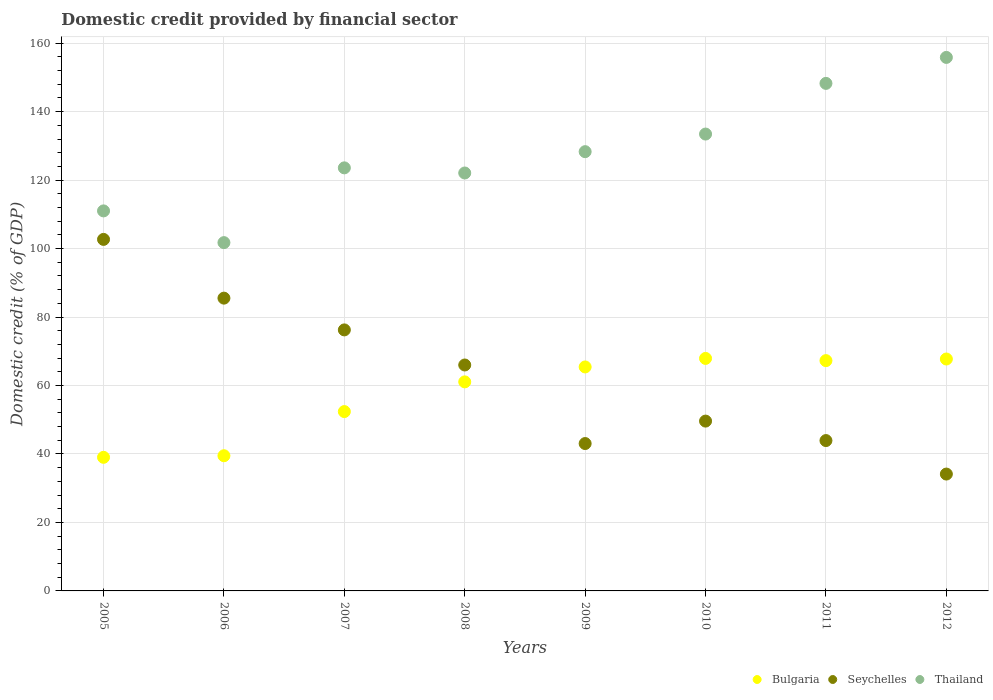How many different coloured dotlines are there?
Your answer should be compact. 3. Is the number of dotlines equal to the number of legend labels?
Offer a very short reply. Yes. What is the domestic credit in Bulgaria in 2010?
Ensure brevity in your answer.  67.92. Across all years, what is the maximum domestic credit in Bulgaria?
Give a very brief answer. 67.92. Across all years, what is the minimum domestic credit in Bulgaria?
Offer a terse response. 39.03. In which year was the domestic credit in Seychelles maximum?
Ensure brevity in your answer.  2005. What is the total domestic credit in Seychelles in the graph?
Ensure brevity in your answer.  501.2. What is the difference between the domestic credit in Bulgaria in 2007 and that in 2009?
Give a very brief answer. -13.04. What is the difference between the domestic credit in Thailand in 2006 and the domestic credit in Bulgaria in 2008?
Offer a terse response. 40.68. What is the average domestic credit in Seychelles per year?
Your answer should be very brief. 62.65. In the year 2006, what is the difference between the domestic credit in Bulgaria and domestic credit in Seychelles?
Ensure brevity in your answer.  -46.04. In how many years, is the domestic credit in Thailand greater than 36 %?
Offer a very short reply. 8. What is the ratio of the domestic credit in Thailand in 2008 to that in 2010?
Offer a very short reply. 0.91. Is the difference between the domestic credit in Bulgaria in 2010 and 2012 greater than the difference between the domestic credit in Seychelles in 2010 and 2012?
Give a very brief answer. No. What is the difference between the highest and the second highest domestic credit in Thailand?
Your response must be concise. 7.59. What is the difference between the highest and the lowest domestic credit in Seychelles?
Your answer should be very brief. 68.55. Is the sum of the domestic credit in Seychelles in 2007 and 2010 greater than the maximum domestic credit in Bulgaria across all years?
Keep it short and to the point. Yes. Is it the case that in every year, the sum of the domestic credit in Seychelles and domestic credit in Bulgaria  is greater than the domestic credit in Thailand?
Provide a short and direct response. No. Is the domestic credit in Seychelles strictly less than the domestic credit in Thailand over the years?
Offer a terse response. Yes. Where does the legend appear in the graph?
Give a very brief answer. Bottom right. What is the title of the graph?
Offer a very short reply. Domestic credit provided by financial sector. What is the label or title of the X-axis?
Offer a terse response. Years. What is the label or title of the Y-axis?
Provide a succinct answer. Domestic credit (% of GDP). What is the Domestic credit (% of GDP) of Bulgaria in 2005?
Your answer should be compact. 39.03. What is the Domestic credit (% of GDP) of Seychelles in 2005?
Provide a short and direct response. 102.69. What is the Domestic credit (% of GDP) of Thailand in 2005?
Give a very brief answer. 111.02. What is the Domestic credit (% of GDP) of Bulgaria in 2006?
Your answer should be compact. 39.49. What is the Domestic credit (% of GDP) of Seychelles in 2006?
Your answer should be compact. 85.53. What is the Domestic credit (% of GDP) in Thailand in 2006?
Your answer should be very brief. 101.75. What is the Domestic credit (% of GDP) of Bulgaria in 2007?
Ensure brevity in your answer.  52.39. What is the Domestic credit (% of GDP) of Seychelles in 2007?
Ensure brevity in your answer.  76.25. What is the Domestic credit (% of GDP) in Thailand in 2007?
Offer a terse response. 123.59. What is the Domestic credit (% of GDP) in Bulgaria in 2008?
Your answer should be compact. 61.07. What is the Domestic credit (% of GDP) of Seychelles in 2008?
Your response must be concise. 66. What is the Domestic credit (% of GDP) of Thailand in 2008?
Your answer should be compact. 122.09. What is the Domestic credit (% of GDP) of Bulgaria in 2009?
Offer a terse response. 65.43. What is the Domestic credit (% of GDP) of Seychelles in 2009?
Provide a succinct answer. 43.05. What is the Domestic credit (% of GDP) in Thailand in 2009?
Your answer should be very brief. 128.32. What is the Domestic credit (% of GDP) of Bulgaria in 2010?
Your response must be concise. 67.92. What is the Domestic credit (% of GDP) in Seychelles in 2010?
Keep it short and to the point. 49.61. What is the Domestic credit (% of GDP) in Thailand in 2010?
Provide a succinct answer. 133.46. What is the Domestic credit (% of GDP) of Bulgaria in 2011?
Give a very brief answer. 67.28. What is the Domestic credit (% of GDP) of Seychelles in 2011?
Make the answer very short. 43.92. What is the Domestic credit (% of GDP) in Thailand in 2011?
Keep it short and to the point. 148.27. What is the Domestic credit (% of GDP) in Bulgaria in 2012?
Provide a short and direct response. 67.75. What is the Domestic credit (% of GDP) of Seychelles in 2012?
Ensure brevity in your answer.  34.14. What is the Domestic credit (% of GDP) of Thailand in 2012?
Offer a very short reply. 155.86. Across all years, what is the maximum Domestic credit (% of GDP) in Bulgaria?
Your response must be concise. 67.92. Across all years, what is the maximum Domestic credit (% of GDP) of Seychelles?
Your answer should be compact. 102.69. Across all years, what is the maximum Domestic credit (% of GDP) of Thailand?
Provide a succinct answer. 155.86. Across all years, what is the minimum Domestic credit (% of GDP) in Bulgaria?
Provide a succinct answer. 39.03. Across all years, what is the minimum Domestic credit (% of GDP) of Seychelles?
Offer a terse response. 34.14. Across all years, what is the minimum Domestic credit (% of GDP) of Thailand?
Your answer should be compact. 101.75. What is the total Domestic credit (% of GDP) in Bulgaria in the graph?
Offer a very short reply. 460.37. What is the total Domestic credit (% of GDP) of Seychelles in the graph?
Offer a terse response. 501.2. What is the total Domestic credit (% of GDP) in Thailand in the graph?
Provide a short and direct response. 1024.36. What is the difference between the Domestic credit (% of GDP) of Bulgaria in 2005 and that in 2006?
Give a very brief answer. -0.47. What is the difference between the Domestic credit (% of GDP) in Seychelles in 2005 and that in 2006?
Your answer should be compact. 17.16. What is the difference between the Domestic credit (% of GDP) of Thailand in 2005 and that in 2006?
Make the answer very short. 9.27. What is the difference between the Domestic credit (% of GDP) of Bulgaria in 2005 and that in 2007?
Provide a succinct answer. -13.36. What is the difference between the Domestic credit (% of GDP) of Seychelles in 2005 and that in 2007?
Ensure brevity in your answer.  26.44. What is the difference between the Domestic credit (% of GDP) in Thailand in 2005 and that in 2007?
Offer a terse response. -12.57. What is the difference between the Domestic credit (% of GDP) in Bulgaria in 2005 and that in 2008?
Ensure brevity in your answer.  -22.04. What is the difference between the Domestic credit (% of GDP) of Seychelles in 2005 and that in 2008?
Keep it short and to the point. 36.69. What is the difference between the Domestic credit (% of GDP) of Thailand in 2005 and that in 2008?
Provide a short and direct response. -11.07. What is the difference between the Domestic credit (% of GDP) of Bulgaria in 2005 and that in 2009?
Your response must be concise. -26.4. What is the difference between the Domestic credit (% of GDP) in Seychelles in 2005 and that in 2009?
Provide a short and direct response. 59.64. What is the difference between the Domestic credit (% of GDP) in Thailand in 2005 and that in 2009?
Provide a succinct answer. -17.3. What is the difference between the Domestic credit (% of GDP) of Bulgaria in 2005 and that in 2010?
Keep it short and to the point. -28.89. What is the difference between the Domestic credit (% of GDP) in Seychelles in 2005 and that in 2010?
Keep it short and to the point. 53.08. What is the difference between the Domestic credit (% of GDP) in Thailand in 2005 and that in 2010?
Make the answer very short. -22.45. What is the difference between the Domestic credit (% of GDP) in Bulgaria in 2005 and that in 2011?
Offer a very short reply. -28.25. What is the difference between the Domestic credit (% of GDP) of Seychelles in 2005 and that in 2011?
Offer a terse response. 58.77. What is the difference between the Domestic credit (% of GDP) in Thailand in 2005 and that in 2011?
Your answer should be very brief. -37.25. What is the difference between the Domestic credit (% of GDP) in Bulgaria in 2005 and that in 2012?
Provide a succinct answer. -28.72. What is the difference between the Domestic credit (% of GDP) of Seychelles in 2005 and that in 2012?
Provide a short and direct response. 68.55. What is the difference between the Domestic credit (% of GDP) in Thailand in 2005 and that in 2012?
Your answer should be compact. -44.84. What is the difference between the Domestic credit (% of GDP) in Bulgaria in 2006 and that in 2007?
Offer a very short reply. -12.9. What is the difference between the Domestic credit (% of GDP) in Seychelles in 2006 and that in 2007?
Give a very brief answer. 9.28. What is the difference between the Domestic credit (% of GDP) in Thailand in 2006 and that in 2007?
Give a very brief answer. -21.84. What is the difference between the Domestic credit (% of GDP) in Bulgaria in 2006 and that in 2008?
Your answer should be compact. -21.58. What is the difference between the Domestic credit (% of GDP) of Seychelles in 2006 and that in 2008?
Your response must be concise. 19.53. What is the difference between the Domestic credit (% of GDP) in Thailand in 2006 and that in 2008?
Make the answer very short. -20.34. What is the difference between the Domestic credit (% of GDP) in Bulgaria in 2006 and that in 2009?
Give a very brief answer. -25.94. What is the difference between the Domestic credit (% of GDP) of Seychelles in 2006 and that in 2009?
Ensure brevity in your answer.  42.48. What is the difference between the Domestic credit (% of GDP) of Thailand in 2006 and that in 2009?
Your answer should be compact. -26.57. What is the difference between the Domestic credit (% of GDP) in Bulgaria in 2006 and that in 2010?
Your response must be concise. -28.43. What is the difference between the Domestic credit (% of GDP) in Seychelles in 2006 and that in 2010?
Provide a succinct answer. 35.92. What is the difference between the Domestic credit (% of GDP) in Thailand in 2006 and that in 2010?
Your answer should be compact. -31.71. What is the difference between the Domestic credit (% of GDP) of Bulgaria in 2006 and that in 2011?
Your answer should be compact. -27.78. What is the difference between the Domestic credit (% of GDP) of Seychelles in 2006 and that in 2011?
Provide a succinct answer. 41.61. What is the difference between the Domestic credit (% of GDP) in Thailand in 2006 and that in 2011?
Provide a short and direct response. -46.52. What is the difference between the Domestic credit (% of GDP) of Bulgaria in 2006 and that in 2012?
Your answer should be compact. -28.26. What is the difference between the Domestic credit (% of GDP) in Seychelles in 2006 and that in 2012?
Make the answer very short. 51.39. What is the difference between the Domestic credit (% of GDP) of Thailand in 2006 and that in 2012?
Your answer should be compact. -54.11. What is the difference between the Domestic credit (% of GDP) in Bulgaria in 2007 and that in 2008?
Your answer should be very brief. -8.68. What is the difference between the Domestic credit (% of GDP) in Seychelles in 2007 and that in 2008?
Make the answer very short. 10.25. What is the difference between the Domestic credit (% of GDP) of Thailand in 2007 and that in 2008?
Give a very brief answer. 1.5. What is the difference between the Domestic credit (% of GDP) of Bulgaria in 2007 and that in 2009?
Your response must be concise. -13.04. What is the difference between the Domestic credit (% of GDP) of Seychelles in 2007 and that in 2009?
Your response must be concise. 33.2. What is the difference between the Domestic credit (% of GDP) of Thailand in 2007 and that in 2009?
Ensure brevity in your answer.  -4.73. What is the difference between the Domestic credit (% of GDP) in Bulgaria in 2007 and that in 2010?
Provide a succinct answer. -15.53. What is the difference between the Domestic credit (% of GDP) of Seychelles in 2007 and that in 2010?
Provide a short and direct response. 26.64. What is the difference between the Domestic credit (% of GDP) of Thailand in 2007 and that in 2010?
Provide a succinct answer. -9.87. What is the difference between the Domestic credit (% of GDP) of Bulgaria in 2007 and that in 2011?
Give a very brief answer. -14.88. What is the difference between the Domestic credit (% of GDP) in Seychelles in 2007 and that in 2011?
Your answer should be compact. 32.33. What is the difference between the Domestic credit (% of GDP) in Thailand in 2007 and that in 2011?
Provide a succinct answer. -24.68. What is the difference between the Domestic credit (% of GDP) of Bulgaria in 2007 and that in 2012?
Your answer should be very brief. -15.36. What is the difference between the Domestic credit (% of GDP) in Seychelles in 2007 and that in 2012?
Provide a succinct answer. 42.11. What is the difference between the Domestic credit (% of GDP) in Thailand in 2007 and that in 2012?
Give a very brief answer. -32.27. What is the difference between the Domestic credit (% of GDP) in Bulgaria in 2008 and that in 2009?
Your response must be concise. -4.36. What is the difference between the Domestic credit (% of GDP) in Seychelles in 2008 and that in 2009?
Offer a terse response. 22.95. What is the difference between the Domestic credit (% of GDP) in Thailand in 2008 and that in 2009?
Offer a terse response. -6.23. What is the difference between the Domestic credit (% of GDP) of Bulgaria in 2008 and that in 2010?
Provide a succinct answer. -6.85. What is the difference between the Domestic credit (% of GDP) in Seychelles in 2008 and that in 2010?
Provide a short and direct response. 16.39. What is the difference between the Domestic credit (% of GDP) of Thailand in 2008 and that in 2010?
Provide a succinct answer. -11.37. What is the difference between the Domestic credit (% of GDP) in Bulgaria in 2008 and that in 2011?
Your answer should be very brief. -6.2. What is the difference between the Domestic credit (% of GDP) of Seychelles in 2008 and that in 2011?
Provide a succinct answer. 22.08. What is the difference between the Domestic credit (% of GDP) in Thailand in 2008 and that in 2011?
Provide a succinct answer. -26.18. What is the difference between the Domestic credit (% of GDP) of Bulgaria in 2008 and that in 2012?
Offer a very short reply. -6.68. What is the difference between the Domestic credit (% of GDP) of Seychelles in 2008 and that in 2012?
Your answer should be very brief. 31.86. What is the difference between the Domestic credit (% of GDP) in Thailand in 2008 and that in 2012?
Provide a short and direct response. -33.77. What is the difference between the Domestic credit (% of GDP) in Bulgaria in 2009 and that in 2010?
Your response must be concise. -2.49. What is the difference between the Domestic credit (% of GDP) in Seychelles in 2009 and that in 2010?
Your answer should be very brief. -6.56. What is the difference between the Domestic credit (% of GDP) in Thailand in 2009 and that in 2010?
Provide a short and direct response. -5.14. What is the difference between the Domestic credit (% of GDP) in Bulgaria in 2009 and that in 2011?
Give a very brief answer. -1.84. What is the difference between the Domestic credit (% of GDP) of Seychelles in 2009 and that in 2011?
Offer a terse response. -0.87. What is the difference between the Domestic credit (% of GDP) in Thailand in 2009 and that in 2011?
Your answer should be very brief. -19.95. What is the difference between the Domestic credit (% of GDP) of Bulgaria in 2009 and that in 2012?
Make the answer very short. -2.32. What is the difference between the Domestic credit (% of GDP) of Seychelles in 2009 and that in 2012?
Give a very brief answer. 8.92. What is the difference between the Domestic credit (% of GDP) of Thailand in 2009 and that in 2012?
Give a very brief answer. -27.54. What is the difference between the Domestic credit (% of GDP) of Bulgaria in 2010 and that in 2011?
Your answer should be very brief. 0.65. What is the difference between the Domestic credit (% of GDP) of Seychelles in 2010 and that in 2011?
Your answer should be compact. 5.69. What is the difference between the Domestic credit (% of GDP) of Thailand in 2010 and that in 2011?
Your response must be concise. -14.8. What is the difference between the Domestic credit (% of GDP) of Bulgaria in 2010 and that in 2012?
Ensure brevity in your answer.  0.17. What is the difference between the Domestic credit (% of GDP) in Seychelles in 2010 and that in 2012?
Make the answer very short. 15.47. What is the difference between the Domestic credit (% of GDP) in Thailand in 2010 and that in 2012?
Give a very brief answer. -22.39. What is the difference between the Domestic credit (% of GDP) in Bulgaria in 2011 and that in 2012?
Provide a succinct answer. -0.47. What is the difference between the Domestic credit (% of GDP) of Seychelles in 2011 and that in 2012?
Your response must be concise. 9.78. What is the difference between the Domestic credit (% of GDP) in Thailand in 2011 and that in 2012?
Offer a terse response. -7.59. What is the difference between the Domestic credit (% of GDP) in Bulgaria in 2005 and the Domestic credit (% of GDP) in Seychelles in 2006?
Offer a very short reply. -46.5. What is the difference between the Domestic credit (% of GDP) in Bulgaria in 2005 and the Domestic credit (% of GDP) in Thailand in 2006?
Offer a terse response. -62.72. What is the difference between the Domestic credit (% of GDP) in Seychelles in 2005 and the Domestic credit (% of GDP) in Thailand in 2006?
Make the answer very short. 0.94. What is the difference between the Domestic credit (% of GDP) of Bulgaria in 2005 and the Domestic credit (% of GDP) of Seychelles in 2007?
Your answer should be very brief. -37.22. What is the difference between the Domestic credit (% of GDP) of Bulgaria in 2005 and the Domestic credit (% of GDP) of Thailand in 2007?
Your answer should be very brief. -84.56. What is the difference between the Domestic credit (% of GDP) of Seychelles in 2005 and the Domestic credit (% of GDP) of Thailand in 2007?
Provide a short and direct response. -20.9. What is the difference between the Domestic credit (% of GDP) of Bulgaria in 2005 and the Domestic credit (% of GDP) of Seychelles in 2008?
Offer a terse response. -26.97. What is the difference between the Domestic credit (% of GDP) in Bulgaria in 2005 and the Domestic credit (% of GDP) in Thailand in 2008?
Keep it short and to the point. -83.06. What is the difference between the Domestic credit (% of GDP) in Seychelles in 2005 and the Domestic credit (% of GDP) in Thailand in 2008?
Provide a short and direct response. -19.4. What is the difference between the Domestic credit (% of GDP) of Bulgaria in 2005 and the Domestic credit (% of GDP) of Seychelles in 2009?
Make the answer very short. -4.03. What is the difference between the Domestic credit (% of GDP) of Bulgaria in 2005 and the Domestic credit (% of GDP) of Thailand in 2009?
Ensure brevity in your answer.  -89.29. What is the difference between the Domestic credit (% of GDP) in Seychelles in 2005 and the Domestic credit (% of GDP) in Thailand in 2009?
Offer a terse response. -25.63. What is the difference between the Domestic credit (% of GDP) in Bulgaria in 2005 and the Domestic credit (% of GDP) in Seychelles in 2010?
Offer a very short reply. -10.58. What is the difference between the Domestic credit (% of GDP) in Bulgaria in 2005 and the Domestic credit (% of GDP) in Thailand in 2010?
Ensure brevity in your answer.  -94.44. What is the difference between the Domestic credit (% of GDP) in Seychelles in 2005 and the Domestic credit (% of GDP) in Thailand in 2010?
Your response must be concise. -30.77. What is the difference between the Domestic credit (% of GDP) in Bulgaria in 2005 and the Domestic credit (% of GDP) in Seychelles in 2011?
Keep it short and to the point. -4.89. What is the difference between the Domestic credit (% of GDP) in Bulgaria in 2005 and the Domestic credit (% of GDP) in Thailand in 2011?
Provide a short and direct response. -109.24. What is the difference between the Domestic credit (% of GDP) of Seychelles in 2005 and the Domestic credit (% of GDP) of Thailand in 2011?
Provide a succinct answer. -45.58. What is the difference between the Domestic credit (% of GDP) in Bulgaria in 2005 and the Domestic credit (% of GDP) in Seychelles in 2012?
Ensure brevity in your answer.  4.89. What is the difference between the Domestic credit (% of GDP) of Bulgaria in 2005 and the Domestic credit (% of GDP) of Thailand in 2012?
Provide a short and direct response. -116.83. What is the difference between the Domestic credit (% of GDP) of Seychelles in 2005 and the Domestic credit (% of GDP) of Thailand in 2012?
Keep it short and to the point. -53.16. What is the difference between the Domestic credit (% of GDP) of Bulgaria in 2006 and the Domestic credit (% of GDP) of Seychelles in 2007?
Keep it short and to the point. -36.76. What is the difference between the Domestic credit (% of GDP) of Bulgaria in 2006 and the Domestic credit (% of GDP) of Thailand in 2007?
Offer a very short reply. -84.1. What is the difference between the Domestic credit (% of GDP) of Seychelles in 2006 and the Domestic credit (% of GDP) of Thailand in 2007?
Ensure brevity in your answer.  -38.06. What is the difference between the Domestic credit (% of GDP) of Bulgaria in 2006 and the Domestic credit (% of GDP) of Seychelles in 2008?
Your answer should be compact. -26.51. What is the difference between the Domestic credit (% of GDP) of Bulgaria in 2006 and the Domestic credit (% of GDP) of Thailand in 2008?
Your answer should be very brief. -82.6. What is the difference between the Domestic credit (% of GDP) in Seychelles in 2006 and the Domestic credit (% of GDP) in Thailand in 2008?
Provide a succinct answer. -36.56. What is the difference between the Domestic credit (% of GDP) in Bulgaria in 2006 and the Domestic credit (% of GDP) in Seychelles in 2009?
Give a very brief answer. -3.56. What is the difference between the Domestic credit (% of GDP) of Bulgaria in 2006 and the Domestic credit (% of GDP) of Thailand in 2009?
Provide a short and direct response. -88.83. What is the difference between the Domestic credit (% of GDP) in Seychelles in 2006 and the Domestic credit (% of GDP) in Thailand in 2009?
Offer a terse response. -42.79. What is the difference between the Domestic credit (% of GDP) in Bulgaria in 2006 and the Domestic credit (% of GDP) in Seychelles in 2010?
Your answer should be very brief. -10.12. What is the difference between the Domestic credit (% of GDP) in Bulgaria in 2006 and the Domestic credit (% of GDP) in Thailand in 2010?
Your answer should be compact. -93.97. What is the difference between the Domestic credit (% of GDP) of Seychelles in 2006 and the Domestic credit (% of GDP) of Thailand in 2010?
Offer a terse response. -47.93. What is the difference between the Domestic credit (% of GDP) in Bulgaria in 2006 and the Domestic credit (% of GDP) in Seychelles in 2011?
Your response must be concise. -4.43. What is the difference between the Domestic credit (% of GDP) of Bulgaria in 2006 and the Domestic credit (% of GDP) of Thailand in 2011?
Give a very brief answer. -108.78. What is the difference between the Domestic credit (% of GDP) of Seychelles in 2006 and the Domestic credit (% of GDP) of Thailand in 2011?
Your response must be concise. -62.74. What is the difference between the Domestic credit (% of GDP) in Bulgaria in 2006 and the Domestic credit (% of GDP) in Seychelles in 2012?
Keep it short and to the point. 5.35. What is the difference between the Domestic credit (% of GDP) of Bulgaria in 2006 and the Domestic credit (% of GDP) of Thailand in 2012?
Offer a very short reply. -116.36. What is the difference between the Domestic credit (% of GDP) in Seychelles in 2006 and the Domestic credit (% of GDP) in Thailand in 2012?
Your response must be concise. -70.33. What is the difference between the Domestic credit (% of GDP) in Bulgaria in 2007 and the Domestic credit (% of GDP) in Seychelles in 2008?
Provide a succinct answer. -13.61. What is the difference between the Domestic credit (% of GDP) of Bulgaria in 2007 and the Domestic credit (% of GDP) of Thailand in 2008?
Your answer should be very brief. -69.7. What is the difference between the Domestic credit (% of GDP) of Seychelles in 2007 and the Domestic credit (% of GDP) of Thailand in 2008?
Give a very brief answer. -45.84. What is the difference between the Domestic credit (% of GDP) in Bulgaria in 2007 and the Domestic credit (% of GDP) in Seychelles in 2009?
Keep it short and to the point. 9.34. What is the difference between the Domestic credit (% of GDP) of Bulgaria in 2007 and the Domestic credit (% of GDP) of Thailand in 2009?
Your answer should be very brief. -75.93. What is the difference between the Domestic credit (% of GDP) in Seychelles in 2007 and the Domestic credit (% of GDP) in Thailand in 2009?
Provide a succinct answer. -52.07. What is the difference between the Domestic credit (% of GDP) in Bulgaria in 2007 and the Domestic credit (% of GDP) in Seychelles in 2010?
Make the answer very short. 2.78. What is the difference between the Domestic credit (% of GDP) in Bulgaria in 2007 and the Domestic credit (% of GDP) in Thailand in 2010?
Keep it short and to the point. -81.07. What is the difference between the Domestic credit (% of GDP) in Seychelles in 2007 and the Domestic credit (% of GDP) in Thailand in 2010?
Give a very brief answer. -57.21. What is the difference between the Domestic credit (% of GDP) in Bulgaria in 2007 and the Domestic credit (% of GDP) in Seychelles in 2011?
Your response must be concise. 8.47. What is the difference between the Domestic credit (% of GDP) in Bulgaria in 2007 and the Domestic credit (% of GDP) in Thailand in 2011?
Offer a very short reply. -95.88. What is the difference between the Domestic credit (% of GDP) of Seychelles in 2007 and the Domestic credit (% of GDP) of Thailand in 2011?
Provide a succinct answer. -72.02. What is the difference between the Domestic credit (% of GDP) in Bulgaria in 2007 and the Domestic credit (% of GDP) in Seychelles in 2012?
Give a very brief answer. 18.25. What is the difference between the Domestic credit (% of GDP) of Bulgaria in 2007 and the Domestic credit (% of GDP) of Thailand in 2012?
Your answer should be compact. -103.46. What is the difference between the Domestic credit (% of GDP) of Seychelles in 2007 and the Domestic credit (% of GDP) of Thailand in 2012?
Provide a succinct answer. -79.6. What is the difference between the Domestic credit (% of GDP) of Bulgaria in 2008 and the Domestic credit (% of GDP) of Seychelles in 2009?
Give a very brief answer. 18.02. What is the difference between the Domestic credit (% of GDP) in Bulgaria in 2008 and the Domestic credit (% of GDP) in Thailand in 2009?
Your answer should be very brief. -67.25. What is the difference between the Domestic credit (% of GDP) of Seychelles in 2008 and the Domestic credit (% of GDP) of Thailand in 2009?
Provide a succinct answer. -62.32. What is the difference between the Domestic credit (% of GDP) in Bulgaria in 2008 and the Domestic credit (% of GDP) in Seychelles in 2010?
Provide a short and direct response. 11.46. What is the difference between the Domestic credit (% of GDP) in Bulgaria in 2008 and the Domestic credit (% of GDP) in Thailand in 2010?
Offer a terse response. -72.39. What is the difference between the Domestic credit (% of GDP) in Seychelles in 2008 and the Domestic credit (% of GDP) in Thailand in 2010?
Ensure brevity in your answer.  -67.46. What is the difference between the Domestic credit (% of GDP) of Bulgaria in 2008 and the Domestic credit (% of GDP) of Seychelles in 2011?
Keep it short and to the point. 17.15. What is the difference between the Domestic credit (% of GDP) of Bulgaria in 2008 and the Domestic credit (% of GDP) of Thailand in 2011?
Keep it short and to the point. -87.2. What is the difference between the Domestic credit (% of GDP) of Seychelles in 2008 and the Domestic credit (% of GDP) of Thailand in 2011?
Give a very brief answer. -82.27. What is the difference between the Domestic credit (% of GDP) in Bulgaria in 2008 and the Domestic credit (% of GDP) in Seychelles in 2012?
Give a very brief answer. 26.93. What is the difference between the Domestic credit (% of GDP) of Bulgaria in 2008 and the Domestic credit (% of GDP) of Thailand in 2012?
Offer a very short reply. -94.79. What is the difference between the Domestic credit (% of GDP) of Seychelles in 2008 and the Domestic credit (% of GDP) of Thailand in 2012?
Keep it short and to the point. -89.85. What is the difference between the Domestic credit (% of GDP) in Bulgaria in 2009 and the Domestic credit (% of GDP) in Seychelles in 2010?
Offer a very short reply. 15.82. What is the difference between the Domestic credit (% of GDP) of Bulgaria in 2009 and the Domestic credit (% of GDP) of Thailand in 2010?
Provide a succinct answer. -68.03. What is the difference between the Domestic credit (% of GDP) in Seychelles in 2009 and the Domestic credit (% of GDP) in Thailand in 2010?
Give a very brief answer. -90.41. What is the difference between the Domestic credit (% of GDP) of Bulgaria in 2009 and the Domestic credit (% of GDP) of Seychelles in 2011?
Give a very brief answer. 21.51. What is the difference between the Domestic credit (% of GDP) of Bulgaria in 2009 and the Domestic credit (% of GDP) of Thailand in 2011?
Your response must be concise. -82.84. What is the difference between the Domestic credit (% of GDP) of Seychelles in 2009 and the Domestic credit (% of GDP) of Thailand in 2011?
Your answer should be very brief. -105.22. What is the difference between the Domestic credit (% of GDP) in Bulgaria in 2009 and the Domestic credit (% of GDP) in Seychelles in 2012?
Your answer should be very brief. 31.29. What is the difference between the Domestic credit (% of GDP) of Bulgaria in 2009 and the Domestic credit (% of GDP) of Thailand in 2012?
Make the answer very short. -90.42. What is the difference between the Domestic credit (% of GDP) of Seychelles in 2009 and the Domestic credit (% of GDP) of Thailand in 2012?
Give a very brief answer. -112.8. What is the difference between the Domestic credit (% of GDP) in Bulgaria in 2010 and the Domestic credit (% of GDP) in Seychelles in 2011?
Make the answer very short. 24. What is the difference between the Domestic credit (% of GDP) of Bulgaria in 2010 and the Domestic credit (% of GDP) of Thailand in 2011?
Give a very brief answer. -80.35. What is the difference between the Domestic credit (% of GDP) of Seychelles in 2010 and the Domestic credit (% of GDP) of Thailand in 2011?
Offer a very short reply. -98.66. What is the difference between the Domestic credit (% of GDP) in Bulgaria in 2010 and the Domestic credit (% of GDP) in Seychelles in 2012?
Keep it short and to the point. 33.78. What is the difference between the Domestic credit (% of GDP) in Bulgaria in 2010 and the Domestic credit (% of GDP) in Thailand in 2012?
Your response must be concise. -87.93. What is the difference between the Domestic credit (% of GDP) in Seychelles in 2010 and the Domestic credit (% of GDP) in Thailand in 2012?
Give a very brief answer. -106.25. What is the difference between the Domestic credit (% of GDP) in Bulgaria in 2011 and the Domestic credit (% of GDP) in Seychelles in 2012?
Your response must be concise. 33.14. What is the difference between the Domestic credit (% of GDP) in Bulgaria in 2011 and the Domestic credit (% of GDP) in Thailand in 2012?
Provide a succinct answer. -88.58. What is the difference between the Domestic credit (% of GDP) in Seychelles in 2011 and the Domestic credit (% of GDP) in Thailand in 2012?
Make the answer very short. -111.94. What is the average Domestic credit (% of GDP) of Bulgaria per year?
Provide a short and direct response. 57.55. What is the average Domestic credit (% of GDP) of Seychelles per year?
Give a very brief answer. 62.65. What is the average Domestic credit (% of GDP) of Thailand per year?
Make the answer very short. 128.05. In the year 2005, what is the difference between the Domestic credit (% of GDP) in Bulgaria and Domestic credit (% of GDP) in Seychelles?
Offer a terse response. -63.66. In the year 2005, what is the difference between the Domestic credit (% of GDP) in Bulgaria and Domestic credit (% of GDP) in Thailand?
Give a very brief answer. -71.99. In the year 2005, what is the difference between the Domestic credit (% of GDP) in Seychelles and Domestic credit (% of GDP) in Thailand?
Give a very brief answer. -8.33. In the year 2006, what is the difference between the Domestic credit (% of GDP) of Bulgaria and Domestic credit (% of GDP) of Seychelles?
Your answer should be compact. -46.04. In the year 2006, what is the difference between the Domestic credit (% of GDP) in Bulgaria and Domestic credit (% of GDP) in Thailand?
Provide a short and direct response. -62.26. In the year 2006, what is the difference between the Domestic credit (% of GDP) in Seychelles and Domestic credit (% of GDP) in Thailand?
Your answer should be very brief. -16.22. In the year 2007, what is the difference between the Domestic credit (% of GDP) of Bulgaria and Domestic credit (% of GDP) of Seychelles?
Your response must be concise. -23.86. In the year 2007, what is the difference between the Domestic credit (% of GDP) in Bulgaria and Domestic credit (% of GDP) in Thailand?
Your response must be concise. -71.2. In the year 2007, what is the difference between the Domestic credit (% of GDP) of Seychelles and Domestic credit (% of GDP) of Thailand?
Provide a short and direct response. -47.34. In the year 2008, what is the difference between the Domestic credit (% of GDP) in Bulgaria and Domestic credit (% of GDP) in Seychelles?
Keep it short and to the point. -4.93. In the year 2008, what is the difference between the Domestic credit (% of GDP) of Bulgaria and Domestic credit (% of GDP) of Thailand?
Make the answer very short. -61.02. In the year 2008, what is the difference between the Domestic credit (% of GDP) in Seychelles and Domestic credit (% of GDP) in Thailand?
Your answer should be very brief. -56.09. In the year 2009, what is the difference between the Domestic credit (% of GDP) of Bulgaria and Domestic credit (% of GDP) of Seychelles?
Provide a short and direct response. 22.38. In the year 2009, what is the difference between the Domestic credit (% of GDP) in Bulgaria and Domestic credit (% of GDP) in Thailand?
Make the answer very short. -62.89. In the year 2009, what is the difference between the Domestic credit (% of GDP) of Seychelles and Domestic credit (% of GDP) of Thailand?
Offer a terse response. -85.27. In the year 2010, what is the difference between the Domestic credit (% of GDP) of Bulgaria and Domestic credit (% of GDP) of Seychelles?
Keep it short and to the point. 18.31. In the year 2010, what is the difference between the Domestic credit (% of GDP) of Bulgaria and Domestic credit (% of GDP) of Thailand?
Give a very brief answer. -65.54. In the year 2010, what is the difference between the Domestic credit (% of GDP) of Seychelles and Domestic credit (% of GDP) of Thailand?
Make the answer very short. -83.85. In the year 2011, what is the difference between the Domestic credit (% of GDP) of Bulgaria and Domestic credit (% of GDP) of Seychelles?
Your response must be concise. 23.35. In the year 2011, what is the difference between the Domestic credit (% of GDP) in Bulgaria and Domestic credit (% of GDP) in Thailand?
Keep it short and to the point. -80.99. In the year 2011, what is the difference between the Domestic credit (% of GDP) of Seychelles and Domestic credit (% of GDP) of Thailand?
Make the answer very short. -104.35. In the year 2012, what is the difference between the Domestic credit (% of GDP) of Bulgaria and Domestic credit (% of GDP) of Seychelles?
Keep it short and to the point. 33.61. In the year 2012, what is the difference between the Domestic credit (% of GDP) in Bulgaria and Domestic credit (% of GDP) in Thailand?
Make the answer very short. -88.11. In the year 2012, what is the difference between the Domestic credit (% of GDP) of Seychelles and Domestic credit (% of GDP) of Thailand?
Your answer should be very brief. -121.72. What is the ratio of the Domestic credit (% of GDP) of Seychelles in 2005 to that in 2006?
Your response must be concise. 1.2. What is the ratio of the Domestic credit (% of GDP) in Thailand in 2005 to that in 2006?
Give a very brief answer. 1.09. What is the ratio of the Domestic credit (% of GDP) in Bulgaria in 2005 to that in 2007?
Provide a short and direct response. 0.74. What is the ratio of the Domestic credit (% of GDP) of Seychelles in 2005 to that in 2007?
Make the answer very short. 1.35. What is the ratio of the Domestic credit (% of GDP) of Thailand in 2005 to that in 2007?
Keep it short and to the point. 0.9. What is the ratio of the Domestic credit (% of GDP) in Bulgaria in 2005 to that in 2008?
Provide a succinct answer. 0.64. What is the ratio of the Domestic credit (% of GDP) in Seychelles in 2005 to that in 2008?
Your answer should be compact. 1.56. What is the ratio of the Domestic credit (% of GDP) of Thailand in 2005 to that in 2008?
Offer a very short reply. 0.91. What is the ratio of the Domestic credit (% of GDP) of Bulgaria in 2005 to that in 2009?
Your answer should be very brief. 0.6. What is the ratio of the Domestic credit (% of GDP) in Seychelles in 2005 to that in 2009?
Make the answer very short. 2.39. What is the ratio of the Domestic credit (% of GDP) of Thailand in 2005 to that in 2009?
Provide a succinct answer. 0.87. What is the ratio of the Domestic credit (% of GDP) of Bulgaria in 2005 to that in 2010?
Provide a succinct answer. 0.57. What is the ratio of the Domestic credit (% of GDP) in Seychelles in 2005 to that in 2010?
Give a very brief answer. 2.07. What is the ratio of the Domestic credit (% of GDP) of Thailand in 2005 to that in 2010?
Offer a terse response. 0.83. What is the ratio of the Domestic credit (% of GDP) in Bulgaria in 2005 to that in 2011?
Your answer should be very brief. 0.58. What is the ratio of the Domestic credit (% of GDP) in Seychelles in 2005 to that in 2011?
Make the answer very short. 2.34. What is the ratio of the Domestic credit (% of GDP) of Thailand in 2005 to that in 2011?
Keep it short and to the point. 0.75. What is the ratio of the Domestic credit (% of GDP) in Bulgaria in 2005 to that in 2012?
Provide a succinct answer. 0.58. What is the ratio of the Domestic credit (% of GDP) of Seychelles in 2005 to that in 2012?
Offer a very short reply. 3.01. What is the ratio of the Domestic credit (% of GDP) in Thailand in 2005 to that in 2012?
Provide a succinct answer. 0.71. What is the ratio of the Domestic credit (% of GDP) in Bulgaria in 2006 to that in 2007?
Provide a short and direct response. 0.75. What is the ratio of the Domestic credit (% of GDP) in Seychelles in 2006 to that in 2007?
Ensure brevity in your answer.  1.12. What is the ratio of the Domestic credit (% of GDP) of Thailand in 2006 to that in 2007?
Ensure brevity in your answer.  0.82. What is the ratio of the Domestic credit (% of GDP) in Bulgaria in 2006 to that in 2008?
Your answer should be very brief. 0.65. What is the ratio of the Domestic credit (% of GDP) of Seychelles in 2006 to that in 2008?
Your response must be concise. 1.3. What is the ratio of the Domestic credit (% of GDP) of Thailand in 2006 to that in 2008?
Offer a terse response. 0.83. What is the ratio of the Domestic credit (% of GDP) of Bulgaria in 2006 to that in 2009?
Give a very brief answer. 0.6. What is the ratio of the Domestic credit (% of GDP) of Seychelles in 2006 to that in 2009?
Ensure brevity in your answer.  1.99. What is the ratio of the Domestic credit (% of GDP) of Thailand in 2006 to that in 2009?
Provide a succinct answer. 0.79. What is the ratio of the Domestic credit (% of GDP) of Bulgaria in 2006 to that in 2010?
Make the answer very short. 0.58. What is the ratio of the Domestic credit (% of GDP) in Seychelles in 2006 to that in 2010?
Your response must be concise. 1.72. What is the ratio of the Domestic credit (% of GDP) of Thailand in 2006 to that in 2010?
Keep it short and to the point. 0.76. What is the ratio of the Domestic credit (% of GDP) in Bulgaria in 2006 to that in 2011?
Make the answer very short. 0.59. What is the ratio of the Domestic credit (% of GDP) in Seychelles in 2006 to that in 2011?
Make the answer very short. 1.95. What is the ratio of the Domestic credit (% of GDP) of Thailand in 2006 to that in 2011?
Your answer should be compact. 0.69. What is the ratio of the Domestic credit (% of GDP) of Bulgaria in 2006 to that in 2012?
Keep it short and to the point. 0.58. What is the ratio of the Domestic credit (% of GDP) in Seychelles in 2006 to that in 2012?
Keep it short and to the point. 2.51. What is the ratio of the Domestic credit (% of GDP) of Thailand in 2006 to that in 2012?
Your answer should be very brief. 0.65. What is the ratio of the Domestic credit (% of GDP) of Bulgaria in 2007 to that in 2008?
Offer a very short reply. 0.86. What is the ratio of the Domestic credit (% of GDP) of Seychelles in 2007 to that in 2008?
Keep it short and to the point. 1.16. What is the ratio of the Domestic credit (% of GDP) in Thailand in 2007 to that in 2008?
Offer a terse response. 1.01. What is the ratio of the Domestic credit (% of GDP) of Bulgaria in 2007 to that in 2009?
Offer a terse response. 0.8. What is the ratio of the Domestic credit (% of GDP) of Seychelles in 2007 to that in 2009?
Offer a very short reply. 1.77. What is the ratio of the Domestic credit (% of GDP) of Thailand in 2007 to that in 2009?
Give a very brief answer. 0.96. What is the ratio of the Domestic credit (% of GDP) of Bulgaria in 2007 to that in 2010?
Ensure brevity in your answer.  0.77. What is the ratio of the Domestic credit (% of GDP) of Seychelles in 2007 to that in 2010?
Keep it short and to the point. 1.54. What is the ratio of the Domestic credit (% of GDP) of Thailand in 2007 to that in 2010?
Give a very brief answer. 0.93. What is the ratio of the Domestic credit (% of GDP) in Bulgaria in 2007 to that in 2011?
Make the answer very short. 0.78. What is the ratio of the Domestic credit (% of GDP) in Seychelles in 2007 to that in 2011?
Ensure brevity in your answer.  1.74. What is the ratio of the Domestic credit (% of GDP) in Thailand in 2007 to that in 2011?
Offer a very short reply. 0.83. What is the ratio of the Domestic credit (% of GDP) of Bulgaria in 2007 to that in 2012?
Keep it short and to the point. 0.77. What is the ratio of the Domestic credit (% of GDP) of Seychelles in 2007 to that in 2012?
Offer a very short reply. 2.23. What is the ratio of the Domestic credit (% of GDP) in Thailand in 2007 to that in 2012?
Offer a very short reply. 0.79. What is the ratio of the Domestic credit (% of GDP) of Bulgaria in 2008 to that in 2009?
Your answer should be very brief. 0.93. What is the ratio of the Domestic credit (% of GDP) in Seychelles in 2008 to that in 2009?
Your response must be concise. 1.53. What is the ratio of the Domestic credit (% of GDP) in Thailand in 2008 to that in 2009?
Your answer should be compact. 0.95. What is the ratio of the Domestic credit (% of GDP) in Bulgaria in 2008 to that in 2010?
Make the answer very short. 0.9. What is the ratio of the Domestic credit (% of GDP) of Seychelles in 2008 to that in 2010?
Your answer should be compact. 1.33. What is the ratio of the Domestic credit (% of GDP) in Thailand in 2008 to that in 2010?
Your answer should be very brief. 0.91. What is the ratio of the Domestic credit (% of GDP) of Bulgaria in 2008 to that in 2011?
Make the answer very short. 0.91. What is the ratio of the Domestic credit (% of GDP) in Seychelles in 2008 to that in 2011?
Offer a very short reply. 1.5. What is the ratio of the Domestic credit (% of GDP) of Thailand in 2008 to that in 2011?
Keep it short and to the point. 0.82. What is the ratio of the Domestic credit (% of GDP) of Bulgaria in 2008 to that in 2012?
Your answer should be compact. 0.9. What is the ratio of the Domestic credit (% of GDP) of Seychelles in 2008 to that in 2012?
Ensure brevity in your answer.  1.93. What is the ratio of the Domestic credit (% of GDP) of Thailand in 2008 to that in 2012?
Ensure brevity in your answer.  0.78. What is the ratio of the Domestic credit (% of GDP) in Bulgaria in 2009 to that in 2010?
Keep it short and to the point. 0.96. What is the ratio of the Domestic credit (% of GDP) of Seychelles in 2009 to that in 2010?
Provide a succinct answer. 0.87. What is the ratio of the Domestic credit (% of GDP) of Thailand in 2009 to that in 2010?
Make the answer very short. 0.96. What is the ratio of the Domestic credit (% of GDP) in Bulgaria in 2009 to that in 2011?
Give a very brief answer. 0.97. What is the ratio of the Domestic credit (% of GDP) in Seychelles in 2009 to that in 2011?
Give a very brief answer. 0.98. What is the ratio of the Domestic credit (% of GDP) of Thailand in 2009 to that in 2011?
Your response must be concise. 0.87. What is the ratio of the Domestic credit (% of GDP) in Bulgaria in 2009 to that in 2012?
Give a very brief answer. 0.97. What is the ratio of the Domestic credit (% of GDP) in Seychelles in 2009 to that in 2012?
Your answer should be compact. 1.26. What is the ratio of the Domestic credit (% of GDP) of Thailand in 2009 to that in 2012?
Provide a short and direct response. 0.82. What is the ratio of the Domestic credit (% of GDP) in Bulgaria in 2010 to that in 2011?
Your response must be concise. 1.01. What is the ratio of the Domestic credit (% of GDP) in Seychelles in 2010 to that in 2011?
Ensure brevity in your answer.  1.13. What is the ratio of the Domestic credit (% of GDP) in Thailand in 2010 to that in 2011?
Give a very brief answer. 0.9. What is the ratio of the Domestic credit (% of GDP) in Seychelles in 2010 to that in 2012?
Make the answer very short. 1.45. What is the ratio of the Domestic credit (% of GDP) in Thailand in 2010 to that in 2012?
Your response must be concise. 0.86. What is the ratio of the Domestic credit (% of GDP) in Bulgaria in 2011 to that in 2012?
Make the answer very short. 0.99. What is the ratio of the Domestic credit (% of GDP) in Seychelles in 2011 to that in 2012?
Your response must be concise. 1.29. What is the ratio of the Domestic credit (% of GDP) of Thailand in 2011 to that in 2012?
Give a very brief answer. 0.95. What is the difference between the highest and the second highest Domestic credit (% of GDP) of Bulgaria?
Make the answer very short. 0.17. What is the difference between the highest and the second highest Domestic credit (% of GDP) in Seychelles?
Give a very brief answer. 17.16. What is the difference between the highest and the second highest Domestic credit (% of GDP) in Thailand?
Offer a very short reply. 7.59. What is the difference between the highest and the lowest Domestic credit (% of GDP) of Bulgaria?
Make the answer very short. 28.89. What is the difference between the highest and the lowest Domestic credit (% of GDP) of Seychelles?
Provide a short and direct response. 68.55. What is the difference between the highest and the lowest Domestic credit (% of GDP) in Thailand?
Ensure brevity in your answer.  54.11. 